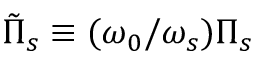<formula> <loc_0><loc_0><loc_500><loc_500>\tilde { \Pi } _ { s } \equiv ( \omega _ { 0 } / \omega _ { s } ) \Pi _ { s }</formula> 